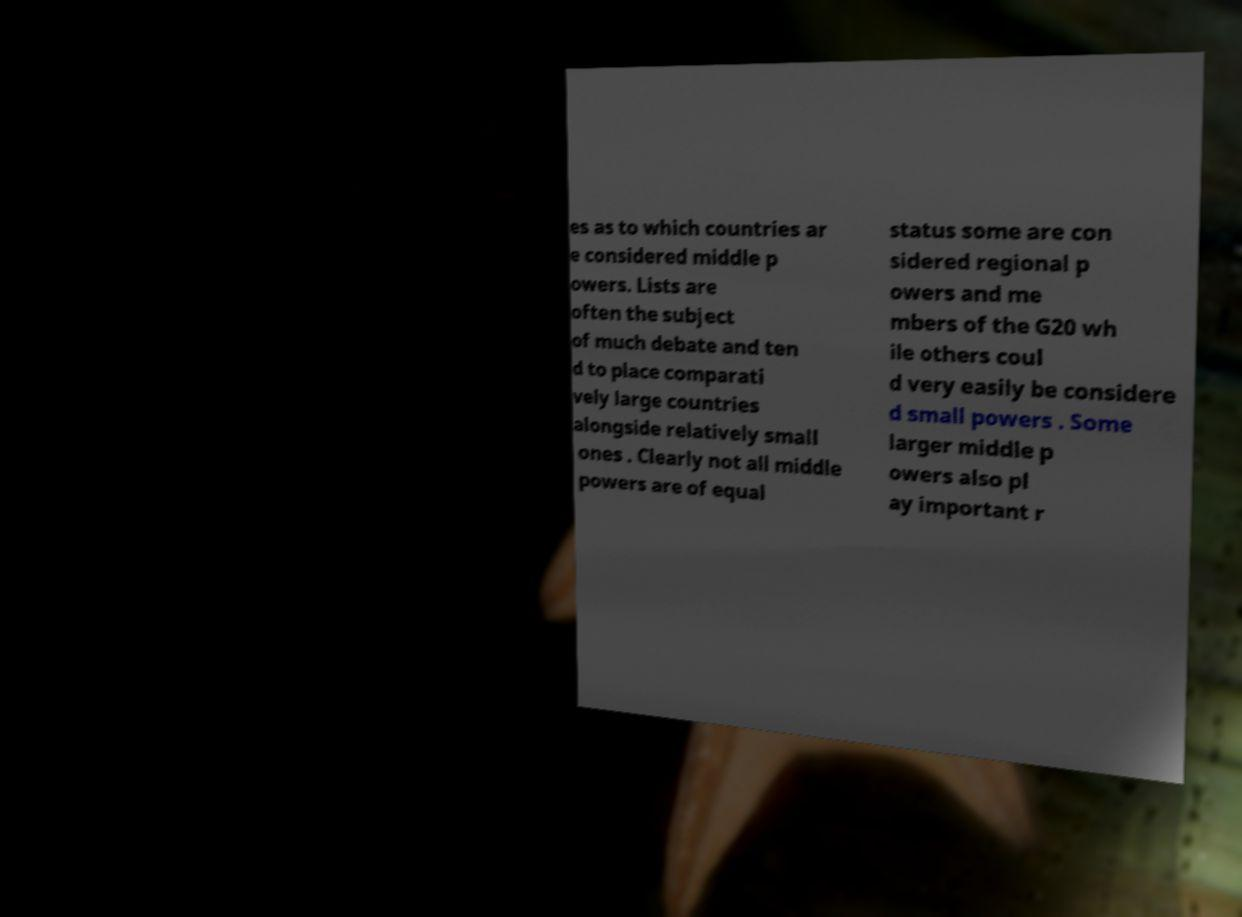For documentation purposes, I need the text within this image transcribed. Could you provide that? es as to which countries ar e considered middle p owers. Lists are often the subject of much debate and ten d to place comparati vely large countries alongside relatively small ones . Clearly not all middle powers are of equal status some are con sidered regional p owers and me mbers of the G20 wh ile others coul d very easily be considere d small powers . Some larger middle p owers also pl ay important r 